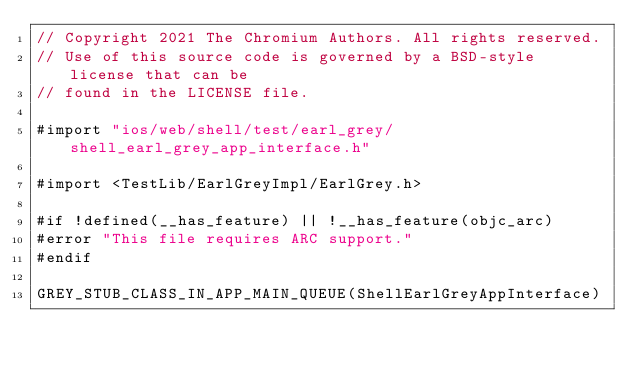Convert code to text. <code><loc_0><loc_0><loc_500><loc_500><_ObjectiveC_>// Copyright 2021 The Chromium Authors. All rights reserved.
// Use of this source code is governed by a BSD-style license that can be
// found in the LICENSE file.

#import "ios/web/shell/test/earl_grey/shell_earl_grey_app_interface.h"

#import <TestLib/EarlGreyImpl/EarlGrey.h>

#if !defined(__has_feature) || !__has_feature(objc_arc)
#error "This file requires ARC support."
#endif

GREY_STUB_CLASS_IN_APP_MAIN_QUEUE(ShellEarlGreyAppInterface)
</code> 